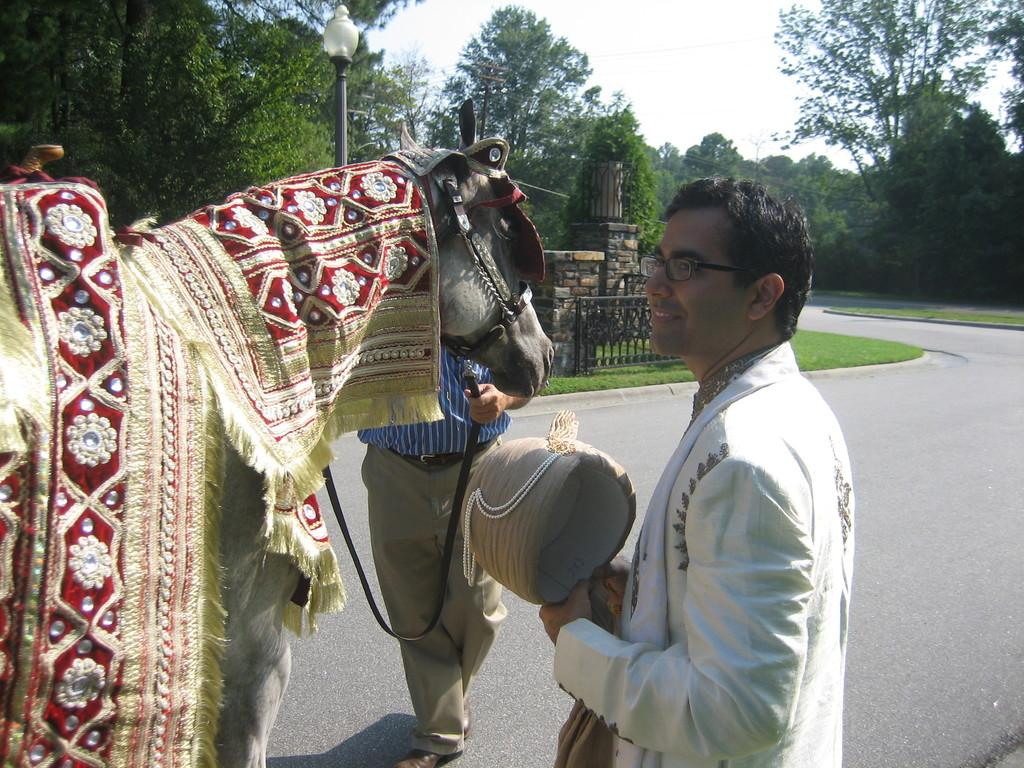Who is present in the image? There is a man in the image. What is the man standing beside? The man is standing beside a horse. Where are the horse and man located? They are on a road. What can be seen on the other sides of the road? There are trees visible on the other sides of the road. What is visible above the road? The sky is visible above the road. What type of banana is being used as a prop in the image? There is no banana present in the image. How does the train affect the man and horse in the image? There is no train present in the image, so it does not affect the man and horse. 